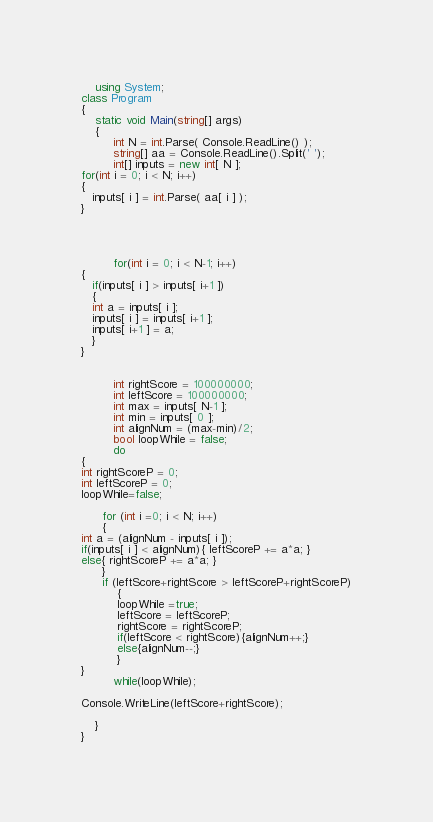<code> <loc_0><loc_0><loc_500><loc_500><_C#_>	using System;
class Program
{
	static void Main(string[] args)
	{
         int N = int.Parse( Console.ReadLine() );
         string[] aa = Console.ReadLine().Split(' ');
         int[] inputs = new int[ N ];
for(int i = 0; i < N; i++)
{
   inputs[ i ] = int.Parse( aa[ i ] );
}




         for(int i = 0; i < N-1; i++)
{
   if(inputs[ i ] > inputs[ i+1 ])
   {
   int a = inputs[ i ];
   inputs[ i ] = inputs[ i+1 ];
   inputs[ i+1 ] = a;
   }
}

         
         int rightScore = 100000000;
         int leftScore = 100000000;
         int max = inputs[ N-1 ];
         int min = inputs[ 0 ];
         int alignNum = (max-min)/2;
         bool loopWhile = false;
         do
{
int rightScoreP = 0;
int leftScoreP = 0;
loopWhile=false;

      for (int i =0; i < N; i++)
      {
int a = (alignNum - inputs[ i ]);
if(inputs[ i ] < alignNum){ leftScoreP += a*a; }
else{ rightScoreP += a*a; }
      }
      if (leftScore+rightScore > leftScoreP+rightScoreP)
          {
          loopWhile =true;
          leftScore = leftScoreP;
          rightScore = rightScoreP;
          if(leftScore < rightScore){alignNum++;}
          else{alignNum--;}
          }
}
         while(loopWhile);

Console.WriteLine(leftScore+rightScore);

	}
}</code> 